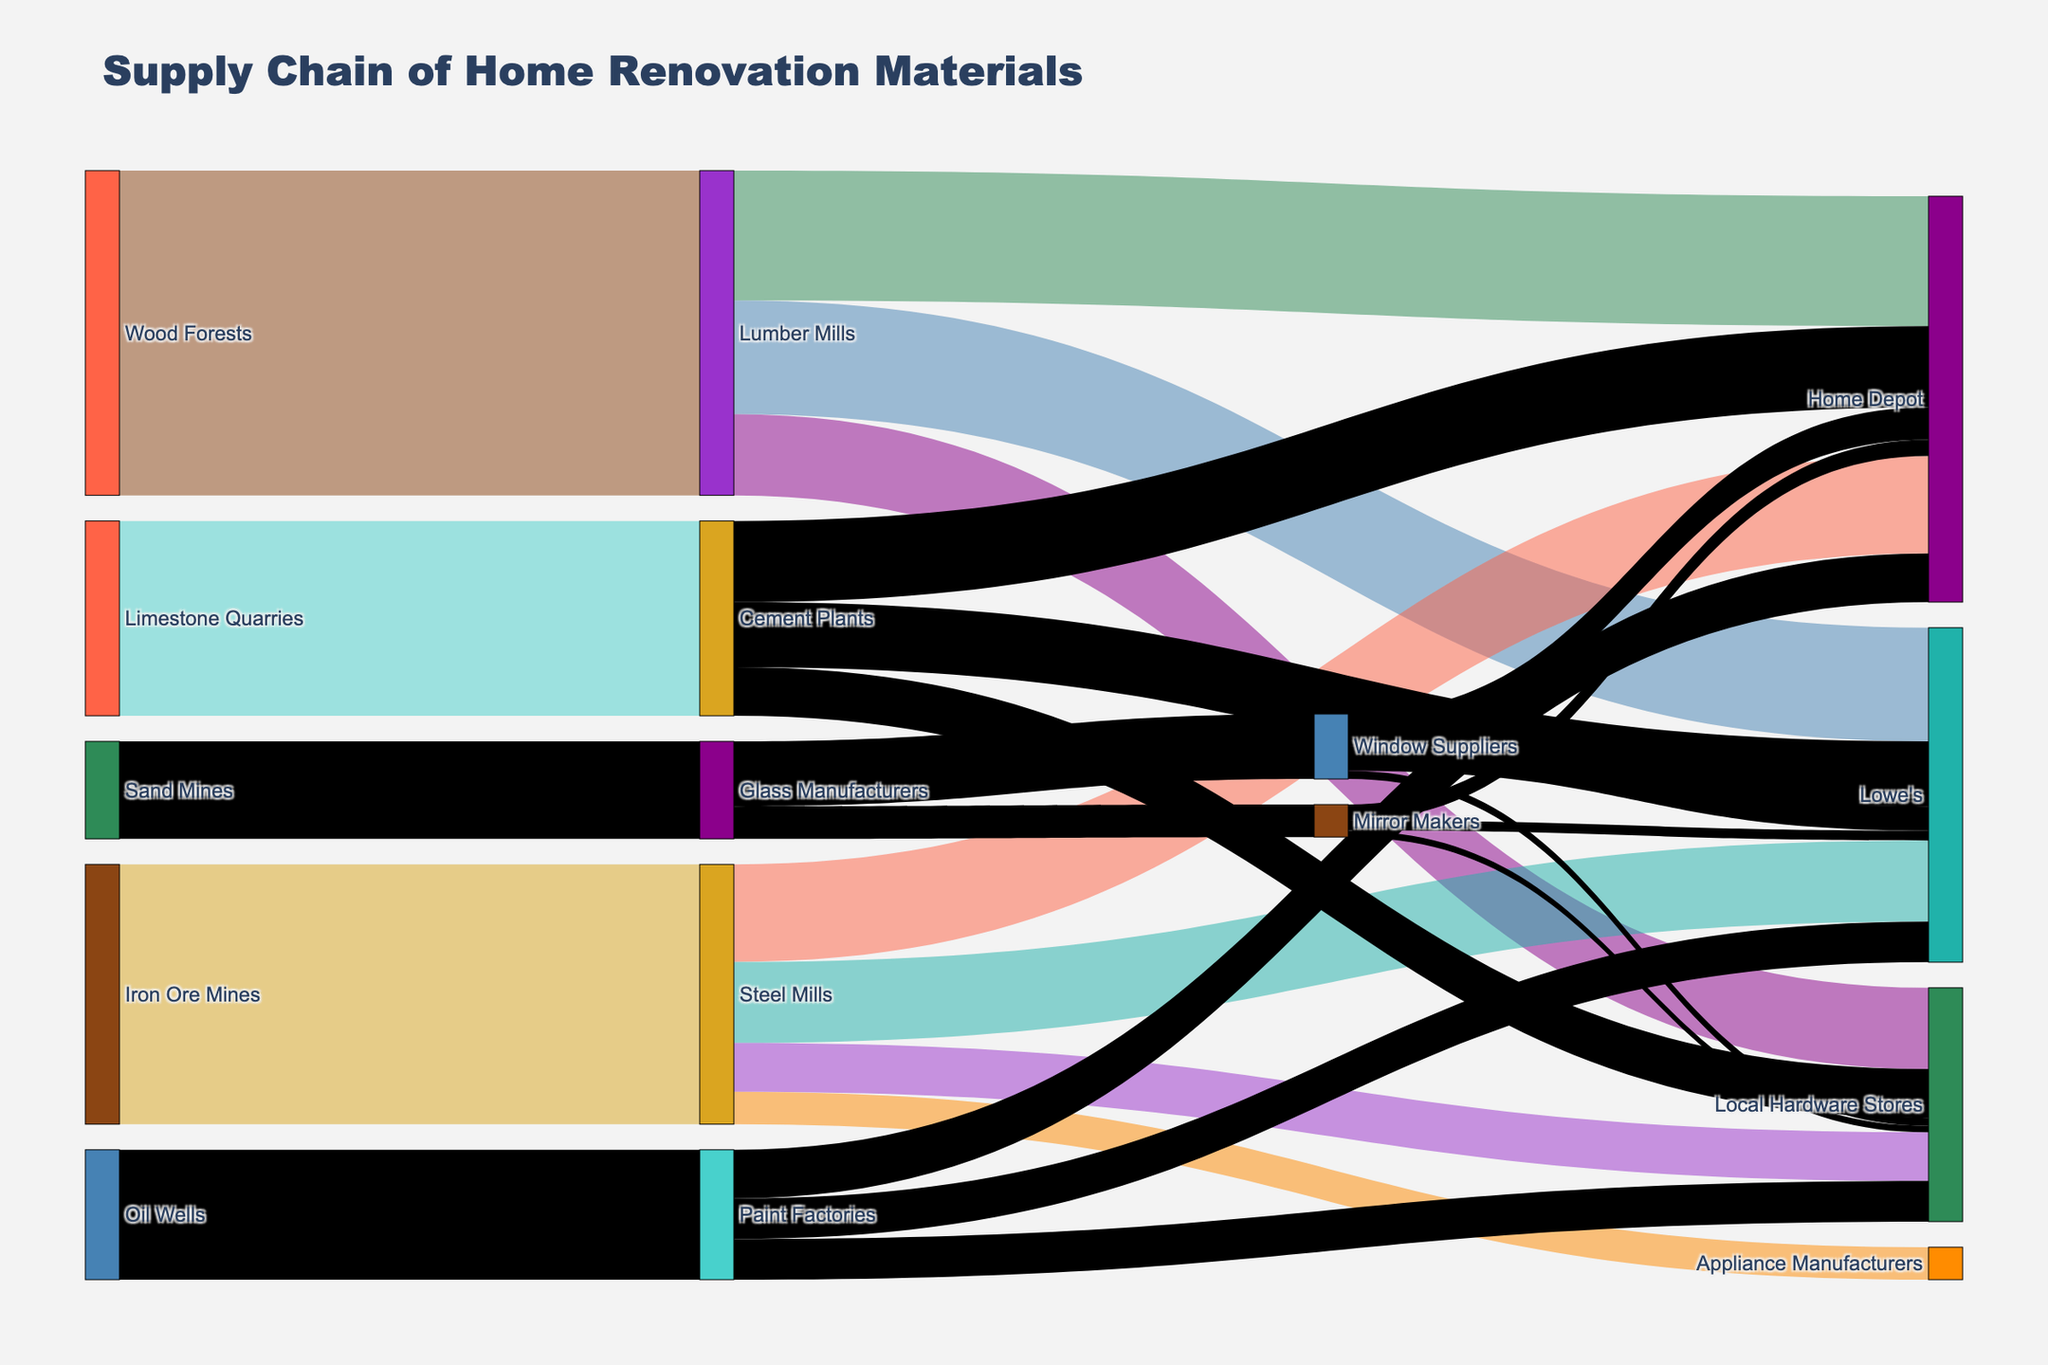Which material source has the highest flow to Home Depot? To answer this, look at the connections between material sources (left nodes) and Home Depot (a right node). Identify which flow has the largest value.
Answer: Lumber Mills Which stores receive materials from the greatest number of sources? Examine each store and count the number of different source connections to that store in the diagram.
Answer: Home Depot What is the total value of materials supplied by Lumber Mills? Sum up all the values flowing from Lumber Mills to its targets: 400 (Home Depot) + 350 (Lowe's) + 250 (Local Hardware Stores) = 1000.
Answer: 1000 How much more material does Home Depot get from Cement Plants compared to Lowe's? Find the values for both connections and subtract the value for Lowe's from the value for Home Depot: 250 (Home Depot) - 200 (Lowe's) = 50.
Answer: 50 What material does Home Depot source from all supply chains? Identify all unique sources connected to Home Depot: Lumber Mills, Steel Mills, Cement Plants, Paint Factories, Window Suppliers, and Mirror Makers.
Answer: Lumber, Steel, Cement, Paint, Windows, Mirrors Comparing material inflow, does Home Depot or Lowe's get more from Paint Factories? Check the values of the links from Paint Factories to Home Depot and Lowe's: Home Depot (150) vs. Lowe's (125).
Answer: Home Depot Which source has the smallest overall flow, and to which targets? Find the source with the smallest sum of outgoing flows: Sand Mines with a total outflow of 300 to Glass Manufacturers, which then splits into Window Suppliers (200) and Mirror Makers (100).
Answer: Sand Mines; Glass Manufacturers What is the total volume of materials that local hardware stores receive? Add up the flow values connected to Local Hardware Stores from all sources: 250 (Lumber Mills) + 150 (Steel Mills) + 150 (Cement Plants) + 125 (Paint Factories) + 25 (Window Suppliers) + 20 (Mirror Makers) = 720.
Answer: 720 What are the intermediate steps for raw materials from Oil Wells to Lowe's? Identify the intermediaries and values in the flow: Oil Wells → Paint Factories (400), followed by Paint Factories → Lowe's (125).
Answer: Paint Factories; 125 How does the flow of iron ore compare from Steel Mills to Home Depot vs. Local Hardware Stores? Check the respective flow values from Steel Mills: Home Depot gets 300, and Local Hardware Stores get 150.
Answer: Home Depot gets 150 more 